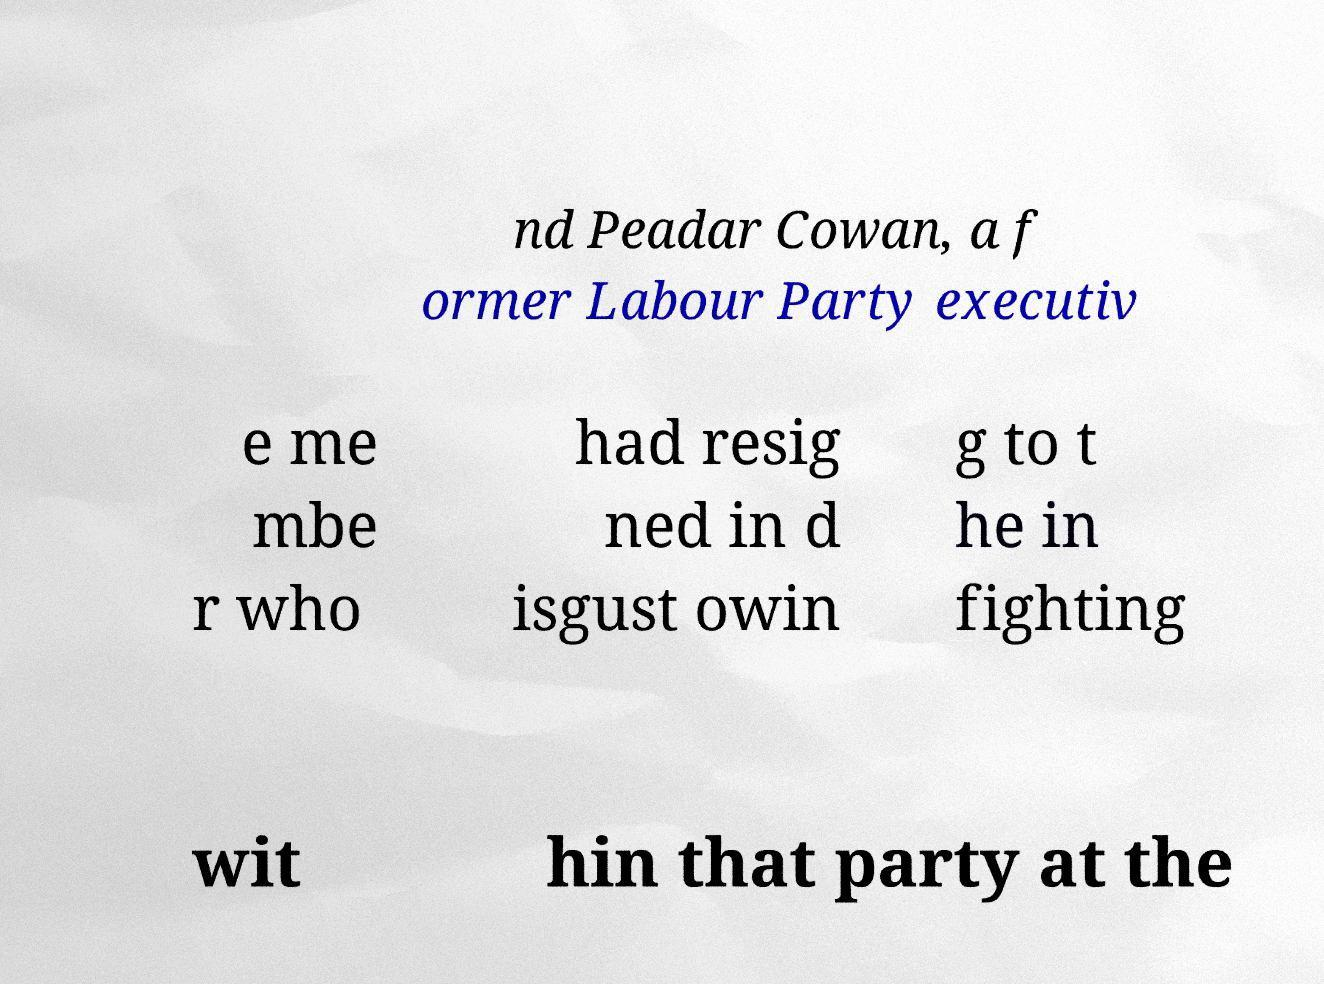Can you accurately transcribe the text from the provided image for me? nd Peadar Cowan, a f ormer Labour Party executiv e me mbe r who had resig ned in d isgust owin g to t he in fighting wit hin that party at the 